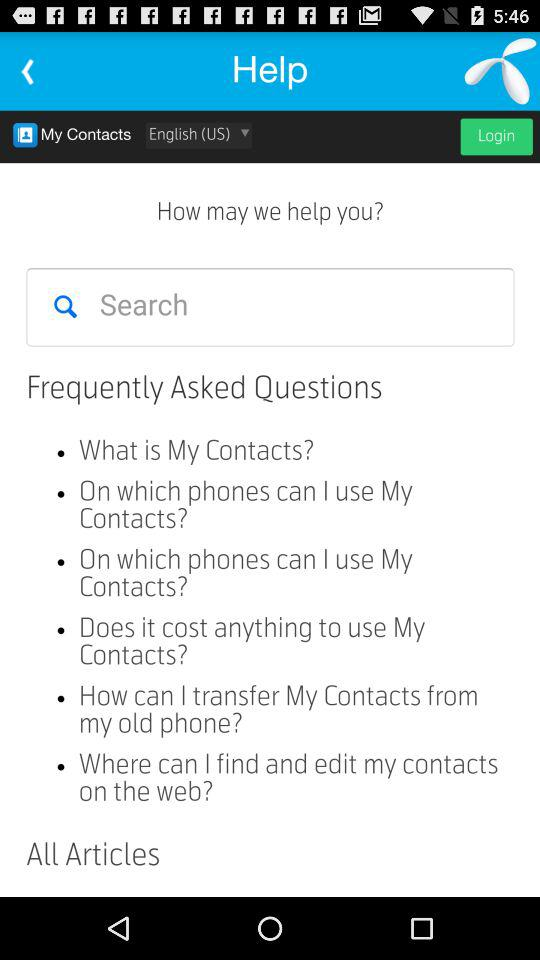Which language option is selected? The selected language option is English (US). 